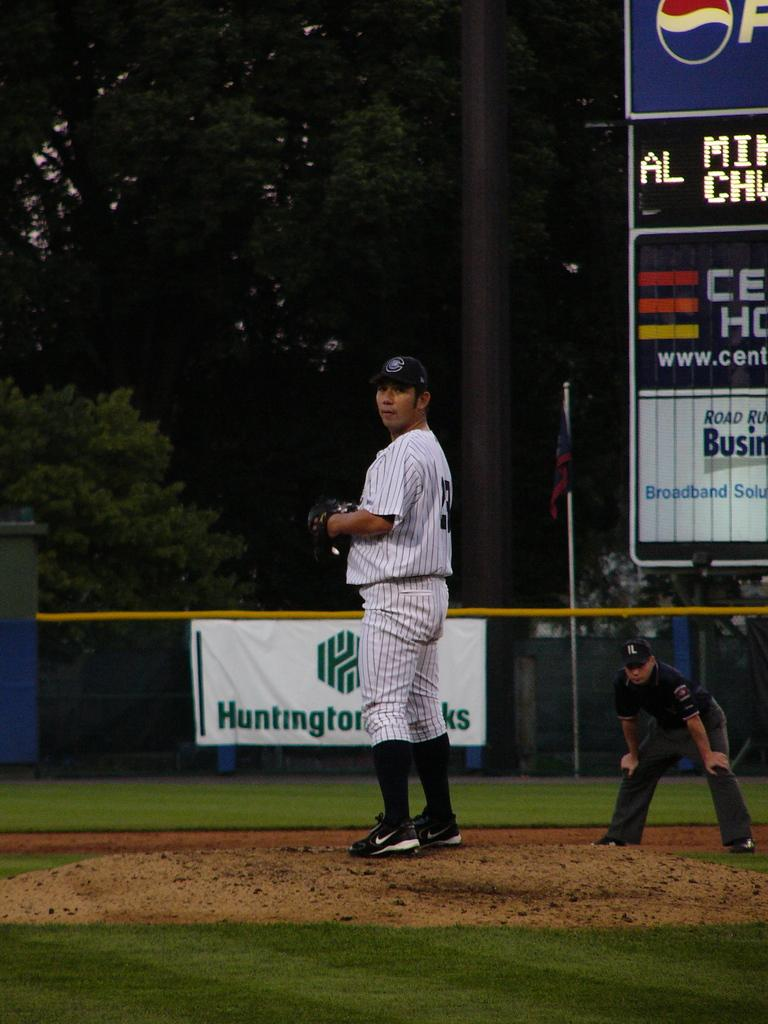<image>
Summarize the visual content of the image. A pitcher wearing number 23 waits to deliver a pitch. 